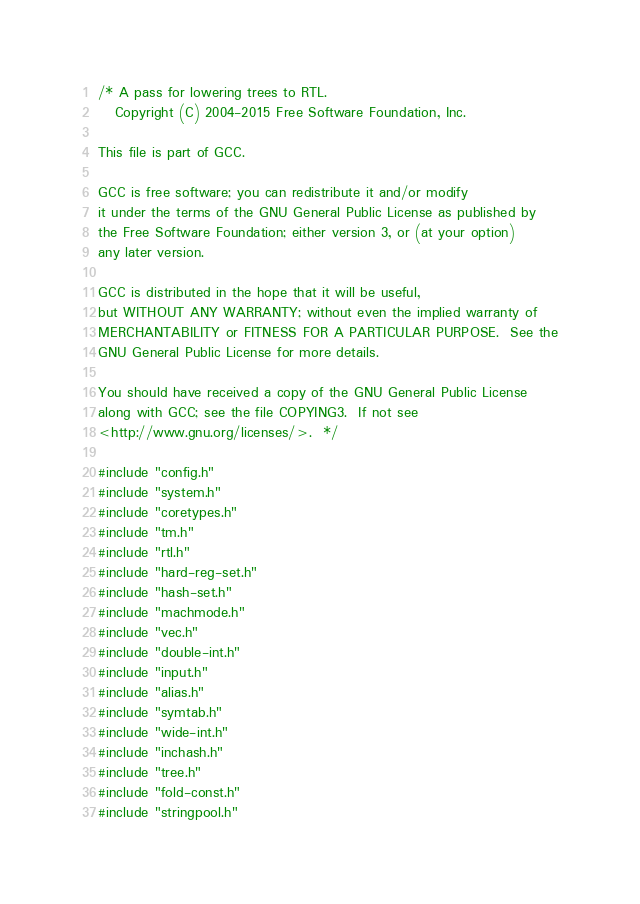Convert code to text. <code><loc_0><loc_0><loc_500><loc_500><_C_>/* A pass for lowering trees to RTL.
   Copyright (C) 2004-2015 Free Software Foundation, Inc.

This file is part of GCC.

GCC is free software; you can redistribute it and/or modify
it under the terms of the GNU General Public License as published by
the Free Software Foundation; either version 3, or (at your option)
any later version.

GCC is distributed in the hope that it will be useful,
but WITHOUT ANY WARRANTY; without even the implied warranty of
MERCHANTABILITY or FITNESS FOR A PARTICULAR PURPOSE.  See the
GNU General Public License for more details.

You should have received a copy of the GNU General Public License
along with GCC; see the file COPYING3.  If not see
<http://www.gnu.org/licenses/>.  */

#include "config.h"
#include "system.h"
#include "coretypes.h"
#include "tm.h"
#include "rtl.h"
#include "hard-reg-set.h"
#include "hash-set.h"
#include "machmode.h"
#include "vec.h"
#include "double-int.h"
#include "input.h"
#include "alias.h"
#include "symtab.h"
#include "wide-int.h"
#include "inchash.h"
#include "tree.h"
#include "fold-const.h"
#include "stringpool.h"</code> 